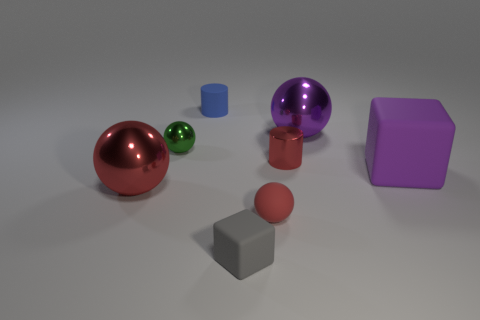Subtract all red rubber spheres. How many spheres are left? 3 Add 2 tiny cyan rubber spheres. How many objects exist? 10 Subtract all red balls. How many balls are left? 2 Subtract 2 spheres. How many spheres are left? 2 Subtract all gray cubes. How many red spheres are left? 2 Add 8 big cyan shiny balls. How many big cyan shiny balls exist? 8 Subtract 0 yellow blocks. How many objects are left? 8 Subtract all cylinders. How many objects are left? 6 Subtract all cyan cylinders. Subtract all cyan blocks. How many cylinders are left? 2 Subtract all small red shiny things. Subtract all large purple metal objects. How many objects are left? 6 